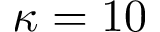Convert formula to latex. <formula><loc_0><loc_0><loc_500><loc_500>\kappa = 1 0</formula> 